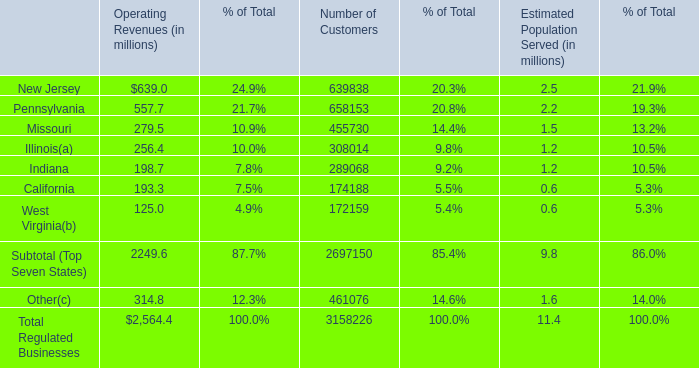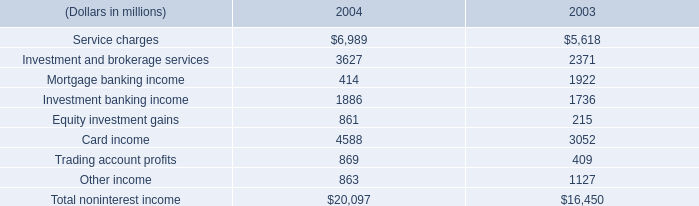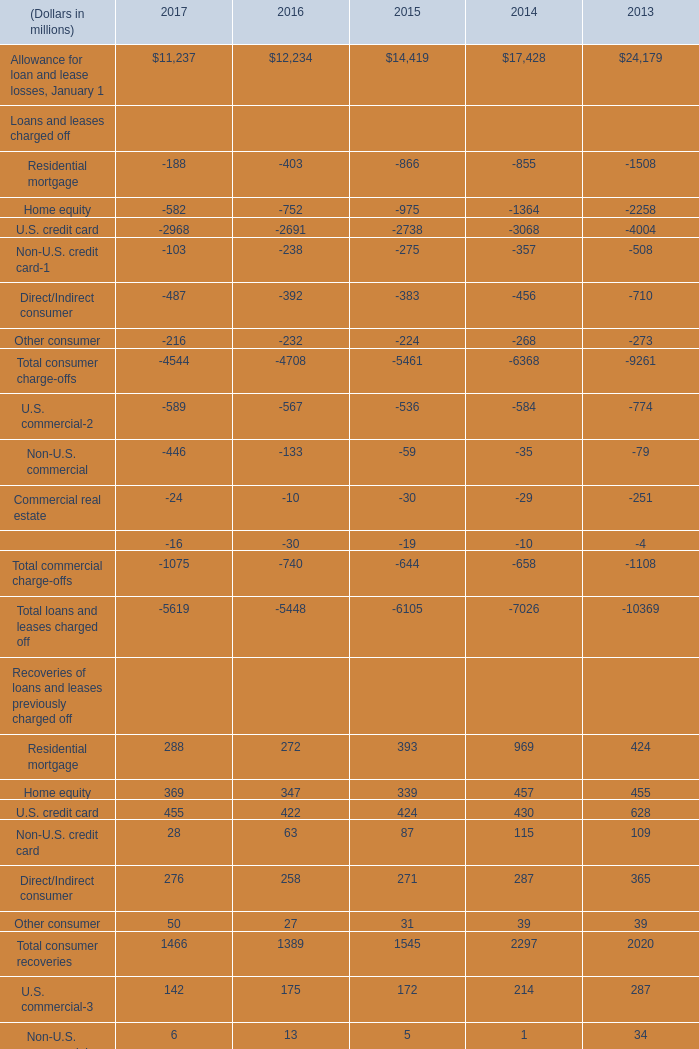What's the total amount of Residential mortgage, Home equity, U.S. credit card and Non-U.S. credit card in 2017? (in million) 
Computations: (((((((-188 - 582) - 2968) - 103) + 288) + 369) + 455) + 28)
Answer: -2701.0. 